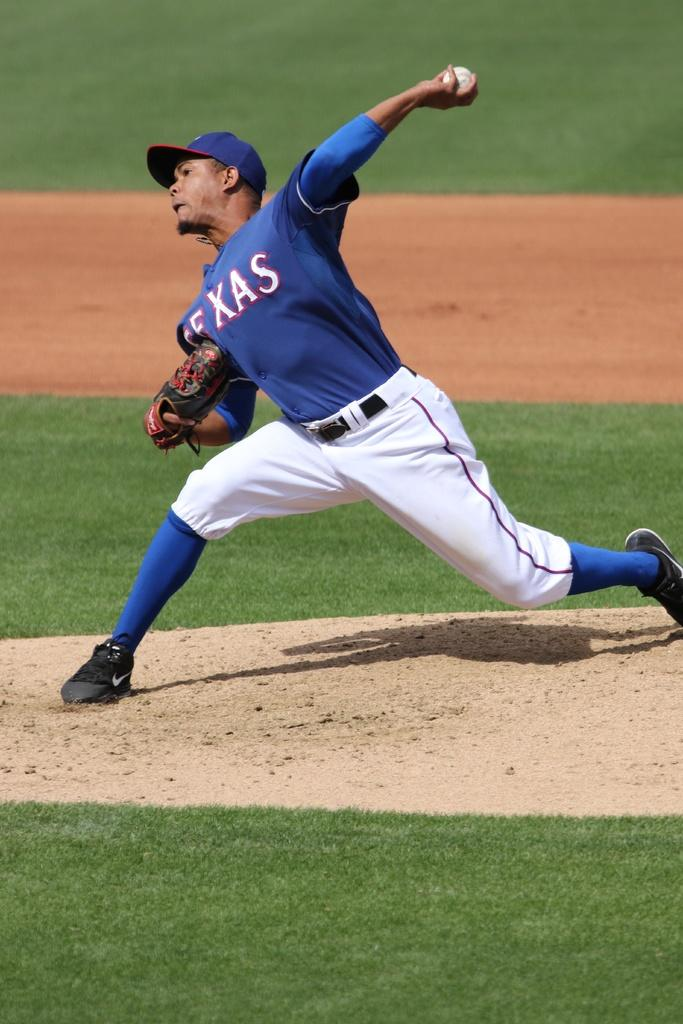<image>
Summarize the visual content of the image. A baseball player has a blue shirt with Texas written on it. 